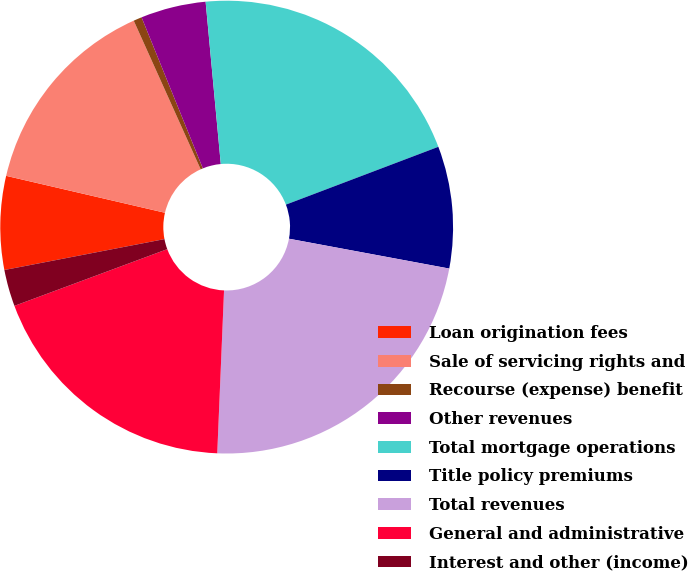Convert chart. <chart><loc_0><loc_0><loc_500><loc_500><pie_chart><fcel>Loan origination fees<fcel>Sale of servicing rights and<fcel>Recourse (expense) benefit<fcel>Other revenues<fcel>Total mortgage operations<fcel>Title policy premiums<fcel>Total revenues<fcel>General and administrative<fcel>Interest and other (income)<nl><fcel>6.67%<fcel>14.63%<fcel>0.6%<fcel>4.65%<fcel>20.71%<fcel>8.7%<fcel>22.73%<fcel>18.68%<fcel>2.62%<nl></chart> 